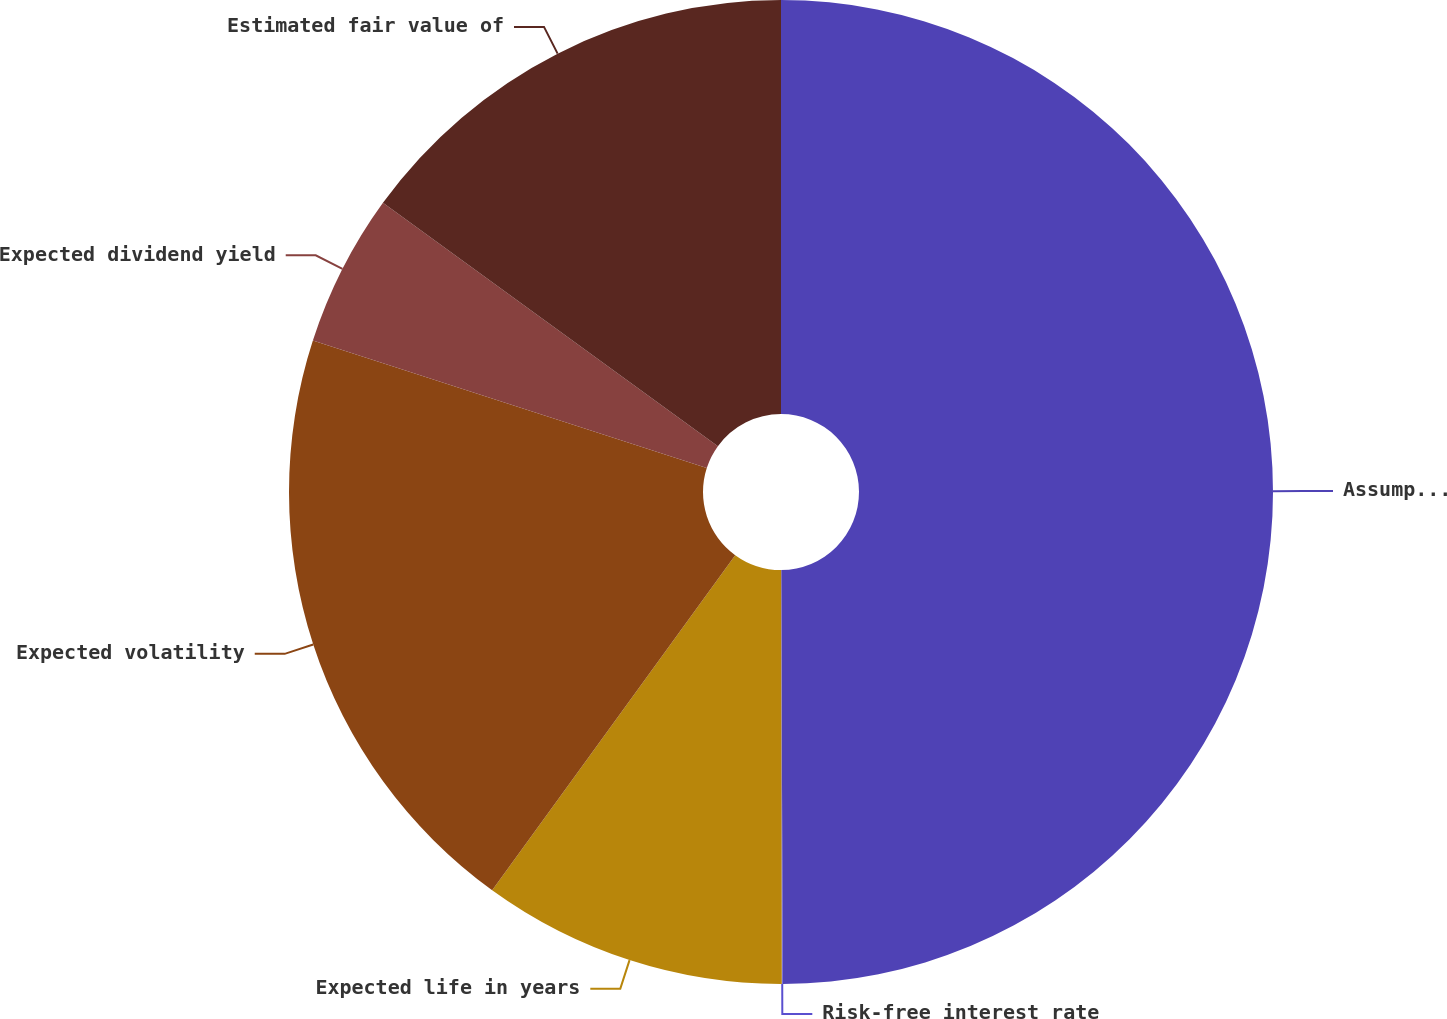Convert chart. <chart><loc_0><loc_0><loc_500><loc_500><pie_chart><fcel>Assumptions<fcel>Risk-free interest rate<fcel>Expected life in years<fcel>Expected volatility<fcel>Expected dividend yield<fcel>Estimated fair value of<nl><fcel>49.94%<fcel>0.03%<fcel>10.01%<fcel>19.99%<fcel>5.02%<fcel>15.0%<nl></chart> 